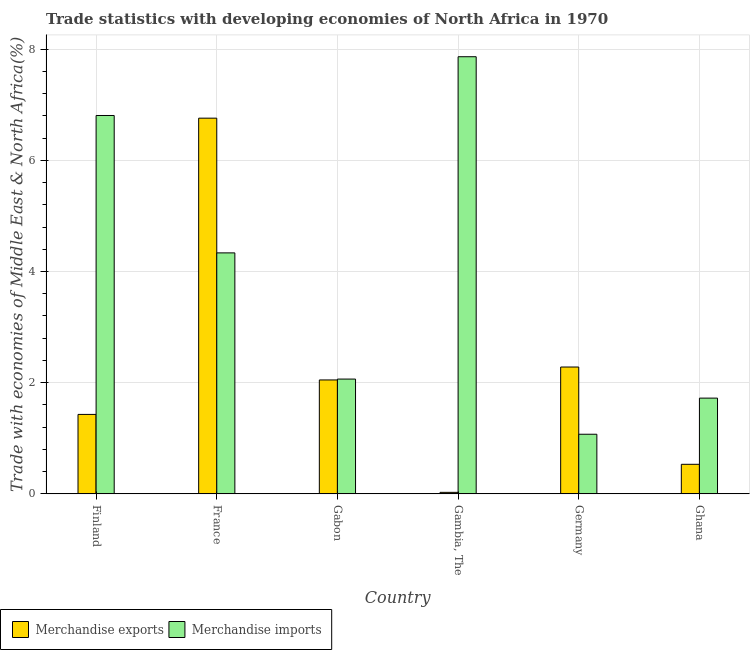How many groups of bars are there?
Offer a terse response. 6. Are the number of bars per tick equal to the number of legend labels?
Provide a succinct answer. Yes. What is the label of the 3rd group of bars from the left?
Your response must be concise. Gabon. In how many cases, is the number of bars for a given country not equal to the number of legend labels?
Provide a succinct answer. 0. What is the merchandise imports in Finland?
Make the answer very short. 6.81. Across all countries, what is the maximum merchandise imports?
Give a very brief answer. 7.86. Across all countries, what is the minimum merchandise exports?
Ensure brevity in your answer.  0.03. In which country was the merchandise exports maximum?
Provide a succinct answer. France. In which country was the merchandise exports minimum?
Your answer should be compact. Gambia, The. What is the total merchandise exports in the graph?
Give a very brief answer. 13.08. What is the difference between the merchandise imports in France and that in Gambia, The?
Ensure brevity in your answer.  -3.53. What is the difference between the merchandise imports in Gabon and the merchandise exports in Finland?
Keep it short and to the point. 0.64. What is the average merchandise imports per country?
Keep it short and to the point. 3.98. What is the difference between the merchandise imports and merchandise exports in Gabon?
Keep it short and to the point. 0.02. In how many countries, is the merchandise imports greater than 6 %?
Provide a succinct answer. 2. What is the ratio of the merchandise imports in Gabon to that in Ghana?
Keep it short and to the point. 1.2. Is the difference between the merchandise exports in France and Germany greater than the difference between the merchandise imports in France and Germany?
Your answer should be compact. Yes. What is the difference between the highest and the second highest merchandise imports?
Your answer should be very brief. 1.06. What is the difference between the highest and the lowest merchandise imports?
Make the answer very short. 6.79. What does the 2nd bar from the right in Gabon represents?
Give a very brief answer. Merchandise exports. How many bars are there?
Give a very brief answer. 12. Are all the bars in the graph horizontal?
Provide a succinct answer. No. Does the graph contain any zero values?
Give a very brief answer. No. Where does the legend appear in the graph?
Offer a very short reply. Bottom left. How are the legend labels stacked?
Ensure brevity in your answer.  Horizontal. What is the title of the graph?
Offer a terse response. Trade statistics with developing economies of North Africa in 1970. What is the label or title of the Y-axis?
Offer a terse response. Trade with economies of Middle East & North Africa(%). What is the Trade with economies of Middle East & North Africa(%) in Merchandise exports in Finland?
Your response must be concise. 1.43. What is the Trade with economies of Middle East & North Africa(%) of Merchandise imports in Finland?
Ensure brevity in your answer.  6.81. What is the Trade with economies of Middle East & North Africa(%) of Merchandise exports in France?
Provide a short and direct response. 6.76. What is the Trade with economies of Middle East & North Africa(%) of Merchandise imports in France?
Your answer should be compact. 4.33. What is the Trade with economies of Middle East & North Africa(%) in Merchandise exports in Gabon?
Your response must be concise. 2.05. What is the Trade with economies of Middle East & North Africa(%) in Merchandise imports in Gabon?
Your answer should be very brief. 2.06. What is the Trade with economies of Middle East & North Africa(%) in Merchandise exports in Gambia, The?
Offer a very short reply. 0.03. What is the Trade with economies of Middle East & North Africa(%) in Merchandise imports in Gambia, The?
Your answer should be very brief. 7.86. What is the Trade with economies of Middle East & North Africa(%) of Merchandise exports in Germany?
Ensure brevity in your answer.  2.28. What is the Trade with economies of Middle East & North Africa(%) in Merchandise imports in Germany?
Offer a terse response. 1.07. What is the Trade with economies of Middle East & North Africa(%) in Merchandise exports in Ghana?
Your answer should be very brief. 0.53. What is the Trade with economies of Middle East & North Africa(%) of Merchandise imports in Ghana?
Provide a short and direct response. 1.72. Across all countries, what is the maximum Trade with economies of Middle East & North Africa(%) in Merchandise exports?
Your answer should be compact. 6.76. Across all countries, what is the maximum Trade with economies of Middle East & North Africa(%) in Merchandise imports?
Offer a very short reply. 7.86. Across all countries, what is the minimum Trade with economies of Middle East & North Africa(%) of Merchandise exports?
Give a very brief answer. 0.03. Across all countries, what is the minimum Trade with economies of Middle East & North Africa(%) in Merchandise imports?
Provide a short and direct response. 1.07. What is the total Trade with economies of Middle East & North Africa(%) in Merchandise exports in the graph?
Offer a very short reply. 13.08. What is the total Trade with economies of Middle East & North Africa(%) in Merchandise imports in the graph?
Your response must be concise. 23.86. What is the difference between the Trade with economies of Middle East & North Africa(%) of Merchandise exports in Finland and that in France?
Provide a short and direct response. -5.33. What is the difference between the Trade with economies of Middle East & North Africa(%) of Merchandise imports in Finland and that in France?
Your answer should be compact. 2.47. What is the difference between the Trade with economies of Middle East & North Africa(%) of Merchandise exports in Finland and that in Gabon?
Make the answer very short. -0.62. What is the difference between the Trade with economies of Middle East & North Africa(%) in Merchandise imports in Finland and that in Gabon?
Make the answer very short. 4.74. What is the difference between the Trade with economies of Middle East & North Africa(%) of Merchandise exports in Finland and that in Gambia, The?
Your answer should be compact. 1.4. What is the difference between the Trade with economies of Middle East & North Africa(%) in Merchandise imports in Finland and that in Gambia, The?
Offer a very short reply. -1.06. What is the difference between the Trade with economies of Middle East & North Africa(%) in Merchandise exports in Finland and that in Germany?
Keep it short and to the point. -0.85. What is the difference between the Trade with economies of Middle East & North Africa(%) in Merchandise imports in Finland and that in Germany?
Provide a succinct answer. 5.73. What is the difference between the Trade with economies of Middle East & North Africa(%) of Merchandise exports in Finland and that in Ghana?
Your answer should be compact. 0.9. What is the difference between the Trade with economies of Middle East & North Africa(%) of Merchandise imports in Finland and that in Ghana?
Your answer should be very brief. 5.08. What is the difference between the Trade with economies of Middle East & North Africa(%) in Merchandise exports in France and that in Gabon?
Give a very brief answer. 4.71. What is the difference between the Trade with economies of Middle East & North Africa(%) of Merchandise imports in France and that in Gabon?
Your response must be concise. 2.27. What is the difference between the Trade with economies of Middle East & North Africa(%) in Merchandise exports in France and that in Gambia, The?
Your answer should be compact. 6.73. What is the difference between the Trade with economies of Middle East & North Africa(%) in Merchandise imports in France and that in Gambia, The?
Make the answer very short. -3.53. What is the difference between the Trade with economies of Middle East & North Africa(%) in Merchandise exports in France and that in Germany?
Make the answer very short. 4.48. What is the difference between the Trade with economies of Middle East & North Africa(%) of Merchandise imports in France and that in Germany?
Offer a terse response. 3.26. What is the difference between the Trade with economies of Middle East & North Africa(%) of Merchandise exports in France and that in Ghana?
Your answer should be compact. 6.23. What is the difference between the Trade with economies of Middle East & North Africa(%) in Merchandise imports in France and that in Ghana?
Your answer should be very brief. 2.61. What is the difference between the Trade with economies of Middle East & North Africa(%) of Merchandise exports in Gabon and that in Gambia, The?
Give a very brief answer. 2.02. What is the difference between the Trade with economies of Middle East & North Africa(%) of Merchandise imports in Gabon and that in Gambia, The?
Give a very brief answer. -5.8. What is the difference between the Trade with economies of Middle East & North Africa(%) in Merchandise exports in Gabon and that in Germany?
Give a very brief answer. -0.23. What is the difference between the Trade with economies of Middle East & North Africa(%) of Merchandise imports in Gabon and that in Germany?
Offer a very short reply. 0.99. What is the difference between the Trade with economies of Middle East & North Africa(%) of Merchandise exports in Gabon and that in Ghana?
Your answer should be compact. 1.52. What is the difference between the Trade with economies of Middle East & North Africa(%) in Merchandise imports in Gabon and that in Ghana?
Make the answer very short. 0.34. What is the difference between the Trade with economies of Middle East & North Africa(%) in Merchandise exports in Gambia, The and that in Germany?
Offer a terse response. -2.25. What is the difference between the Trade with economies of Middle East & North Africa(%) of Merchandise imports in Gambia, The and that in Germany?
Offer a very short reply. 6.79. What is the difference between the Trade with economies of Middle East & North Africa(%) of Merchandise exports in Gambia, The and that in Ghana?
Your answer should be very brief. -0.5. What is the difference between the Trade with economies of Middle East & North Africa(%) in Merchandise imports in Gambia, The and that in Ghana?
Offer a very short reply. 6.14. What is the difference between the Trade with economies of Middle East & North Africa(%) in Merchandise exports in Germany and that in Ghana?
Your answer should be very brief. 1.75. What is the difference between the Trade with economies of Middle East & North Africa(%) of Merchandise imports in Germany and that in Ghana?
Provide a short and direct response. -0.65. What is the difference between the Trade with economies of Middle East & North Africa(%) of Merchandise exports in Finland and the Trade with economies of Middle East & North Africa(%) of Merchandise imports in France?
Provide a short and direct response. -2.91. What is the difference between the Trade with economies of Middle East & North Africa(%) in Merchandise exports in Finland and the Trade with economies of Middle East & North Africa(%) in Merchandise imports in Gabon?
Make the answer very short. -0.64. What is the difference between the Trade with economies of Middle East & North Africa(%) of Merchandise exports in Finland and the Trade with economies of Middle East & North Africa(%) of Merchandise imports in Gambia, The?
Ensure brevity in your answer.  -6.43. What is the difference between the Trade with economies of Middle East & North Africa(%) of Merchandise exports in Finland and the Trade with economies of Middle East & North Africa(%) of Merchandise imports in Germany?
Provide a short and direct response. 0.36. What is the difference between the Trade with economies of Middle East & North Africa(%) of Merchandise exports in Finland and the Trade with economies of Middle East & North Africa(%) of Merchandise imports in Ghana?
Your response must be concise. -0.29. What is the difference between the Trade with economies of Middle East & North Africa(%) of Merchandise exports in France and the Trade with economies of Middle East & North Africa(%) of Merchandise imports in Gabon?
Offer a terse response. 4.69. What is the difference between the Trade with economies of Middle East & North Africa(%) of Merchandise exports in France and the Trade with economies of Middle East & North Africa(%) of Merchandise imports in Gambia, The?
Your answer should be compact. -1.1. What is the difference between the Trade with economies of Middle East & North Africa(%) in Merchandise exports in France and the Trade with economies of Middle East & North Africa(%) in Merchandise imports in Germany?
Offer a very short reply. 5.69. What is the difference between the Trade with economies of Middle East & North Africa(%) in Merchandise exports in France and the Trade with economies of Middle East & North Africa(%) in Merchandise imports in Ghana?
Make the answer very short. 5.04. What is the difference between the Trade with economies of Middle East & North Africa(%) of Merchandise exports in Gabon and the Trade with economies of Middle East & North Africa(%) of Merchandise imports in Gambia, The?
Provide a succinct answer. -5.81. What is the difference between the Trade with economies of Middle East & North Africa(%) in Merchandise exports in Gabon and the Trade with economies of Middle East & North Africa(%) in Merchandise imports in Germany?
Give a very brief answer. 0.98. What is the difference between the Trade with economies of Middle East & North Africa(%) in Merchandise exports in Gabon and the Trade with economies of Middle East & North Africa(%) in Merchandise imports in Ghana?
Provide a short and direct response. 0.33. What is the difference between the Trade with economies of Middle East & North Africa(%) in Merchandise exports in Gambia, The and the Trade with economies of Middle East & North Africa(%) in Merchandise imports in Germany?
Your answer should be very brief. -1.05. What is the difference between the Trade with economies of Middle East & North Africa(%) in Merchandise exports in Gambia, The and the Trade with economies of Middle East & North Africa(%) in Merchandise imports in Ghana?
Keep it short and to the point. -1.7. What is the difference between the Trade with economies of Middle East & North Africa(%) of Merchandise exports in Germany and the Trade with economies of Middle East & North Africa(%) of Merchandise imports in Ghana?
Offer a terse response. 0.56. What is the average Trade with economies of Middle East & North Africa(%) in Merchandise exports per country?
Give a very brief answer. 2.18. What is the average Trade with economies of Middle East & North Africa(%) of Merchandise imports per country?
Offer a very short reply. 3.98. What is the difference between the Trade with economies of Middle East & North Africa(%) in Merchandise exports and Trade with economies of Middle East & North Africa(%) in Merchandise imports in Finland?
Your answer should be compact. -5.38. What is the difference between the Trade with economies of Middle East & North Africa(%) in Merchandise exports and Trade with economies of Middle East & North Africa(%) in Merchandise imports in France?
Ensure brevity in your answer.  2.42. What is the difference between the Trade with economies of Middle East & North Africa(%) in Merchandise exports and Trade with economies of Middle East & North Africa(%) in Merchandise imports in Gabon?
Your answer should be very brief. -0.02. What is the difference between the Trade with economies of Middle East & North Africa(%) of Merchandise exports and Trade with economies of Middle East & North Africa(%) of Merchandise imports in Gambia, The?
Provide a short and direct response. -7.84. What is the difference between the Trade with economies of Middle East & North Africa(%) of Merchandise exports and Trade with economies of Middle East & North Africa(%) of Merchandise imports in Germany?
Make the answer very short. 1.21. What is the difference between the Trade with economies of Middle East & North Africa(%) of Merchandise exports and Trade with economies of Middle East & North Africa(%) of Merchandise imports in Ghana?
Keep it short and to the point. -1.19. What is the ratio of the Trade with economies of Middle East & North Africa(%) in Merchandise exports in Finland to that in France?
Your response must be concise. 0.21. What is the ratio of the Trade with economies of Middle East & North Africa(%) of Merchandise imports in Finland to that in France?
Your answer should be very brief. 1.57. What is the ratio of the Trade with economies of Middle East & North Africa(%) in Merchandise exports in Finland to that in Gabon?
Your response must be concise. 0.7. What is the ratio of the Trade with economies of Middle East & North Africa(%) of Merchandise imports in Finland to that in Gabon?
Give a very brief answer. 3.3. What is the ratio of the Trade with economies of Middle East & North Africa(%) in Merchandise exports in Finland to that in Gambia, The?
Provide a short and direct response. 52.58. What is the ratio of the Trade with economies of Middle East & North Africa(%) of Merchandise imports in Finland to that in Gambia, The?
Offer a very short reply. 0.87. What is the ratio of the Trade with economies of Middle East & North Africa(%) in Merchandise exports in Finland to that in Germany?
Ensure brevity in your answer.  0.63. What is the ratio of the Trade with economies of Middle East & North Africa(%) in Merchandise imports in Finland to that in Germany?
Offer a terse response. 6.35. What is the ratio of the Trade with economies of Middle East & North Africa(%) of Merchandise exports in Finland to that in Ghana?
Provide a short and direct response. 2.69. What is the ratio of the Trade with economies of Middle East & North Africa(%) in Merchandise imports in Finland to that in Ghana?
Keep it short and to the point. 3.95. What is the ratio of the Trade with economies of Middle East & North Africa(%) of Merchandise exports in France to that in Gabon?
Provide a succinct answer. 3.3. What is the ratio of the Trade with economies of Middle East & North Africa(%) in Merchandise imports in France to that in Gabon?
Your answer should be compact. 2.1. What is the ratio of the Trade with economies of Middle East & North Africa(%) in Merchandise exports in France to that in Gambia, The?
Offer a very short reply. 248.65. What is the ratio of the Trade with economies of Middle East & North Africa(%) of Merchandise imports in France to that in Gambia, The?
Ensure brevity in your answer.  0.55. What is the ratio of the Trade with economies of Middle East & North Africa(%) of Merchandise exports in France to that in Germany?
Give a very brief answer. 2.96. What is the ratio of the Trade with economies of Middle East & North Africa(%) of Merchandise imports in France to that in Germany?
Your answer should be very brief. 4.04. What is the ratio of the Trade with economies of Middle East & North Africa(%) in Merchandise exports in France to that in Ghana?
Your answer should be compact. 12.71. What is the ratio of the Trade with economies of Middle East & North Africa(%) of Merchandise imports in France to that in Ghana?
Ensure brevity in your answer.  2.52. What is the ratio of the Trade with economies of Middle East & North Africa(%) of Merchandise exports in Gabon to that in Gambia, The?
Your answer should be very brief. 75.39. What is the ratio of the Trade with economies of Middle East & North Africa(%) of Merchandise imports in Gabon to that in Gambia, The?
Make the answer very short. 0.26. What is the ratio of the Trade with economies of Middle East & North Africa(%) of Merchandise exports in Gabon to that in Germany?
Keep it short and to the point. 0.9. What is the ratio of the Trade with economies of Middle East & North Africa(%) of Merchandise imports in Gabon to that in Germany?
Keep it short and to the point. 1.93. What is the ratio of the Trade with economies of Middle East & North Africa(%) in Merchandise exports in Gabon to that in Ghana?
Give a very brief answer. 3.85. What is the ratio of the Trade with economies of Middle East & North Africa(%) of Merchandise imports in Gabon to that in Ghana?
Provide a short and direct response. 1.2. What is the ratio of the Trade with economies of Middle East & North Africa(%) in Merchandise exports in Gambia, The to that in Germany?
Your response must be concise. 0.01. What is the ratio of the Trade with economies of Middle East & North Africa(%) of Merchandise imports in Gambia, The to that in Germany?
Keep it short and to the point. 7.33. What is the ratio of the Trade with economies of Middle East & North Africa(%) of Merchandise exports in Gambia, The to that in Ghana?
Your answer should be compact. 0.05. What is the ratio of the Trade with economies of Middle East & North Africa(%) in Merchandise imports in Gambia, The to that in Ghana?
Your answer should be very brief. 4.57. What is the ratio of the Trade with economies of Middle East & North Africa(%) in Merchandise exports in Germany to that in Ghana?
Offer a very short reply. 4.29. What is the ratio of the Trade with economies of Middle East & North Africa(%) of Merchandise imports in Germany to that in Ghana?
Your answer should be very brief. 0.62. What is the difference between the highest and the second highest Trade with economies of Middle East & North Africa(%) of Merchandise exports?
Provide a succinct answer. 4.48. What is the difference between the highest and the second highest Trade with economies of Middle East & North Africa(%) of Merchandise imports?
Provide a succinct answer. 1.06. What is the difference between the highest and the lowest Trade with economies of Middle East & North Africa(%) in Merchandise exports?
Provide a short and direct response. 6.73. What is the difference between the highest and the lowest Trade with economies of Middle East & North Africa(%) in Merchandise imports?
Make the answer very short. 6.79. 